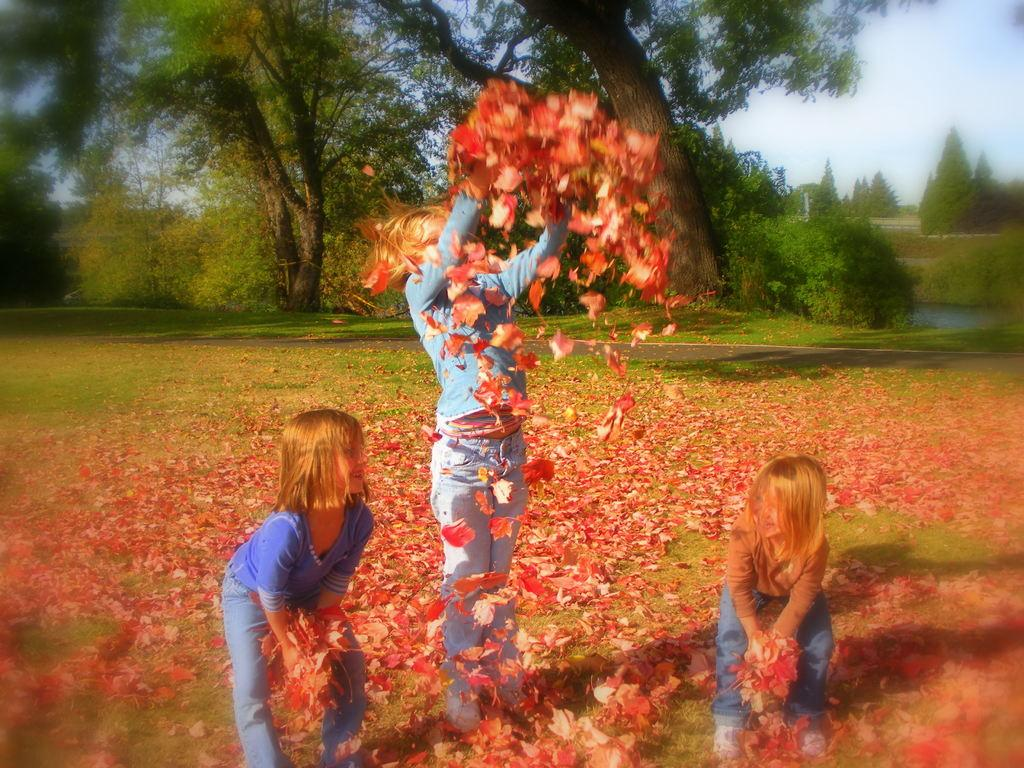How many kids are in the image? There are three kids in the center of the image. What are the kids holding in their hands? The kids are holding dry leaves. What can be seen in the background of the image? There is a sky, trees, grass, and dry leaves visible in the background of the image. Can you see a crook in the image? There is no crook present in the image. What type of rabbit can be seen hopping near the kids in the image? There is no rabbit present in the image. 